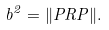Convert formula to latex. <formula><loc_0><loc_0><loc_500><loc_500>b ^ { 2 } = \| P R P \| .</formula> 